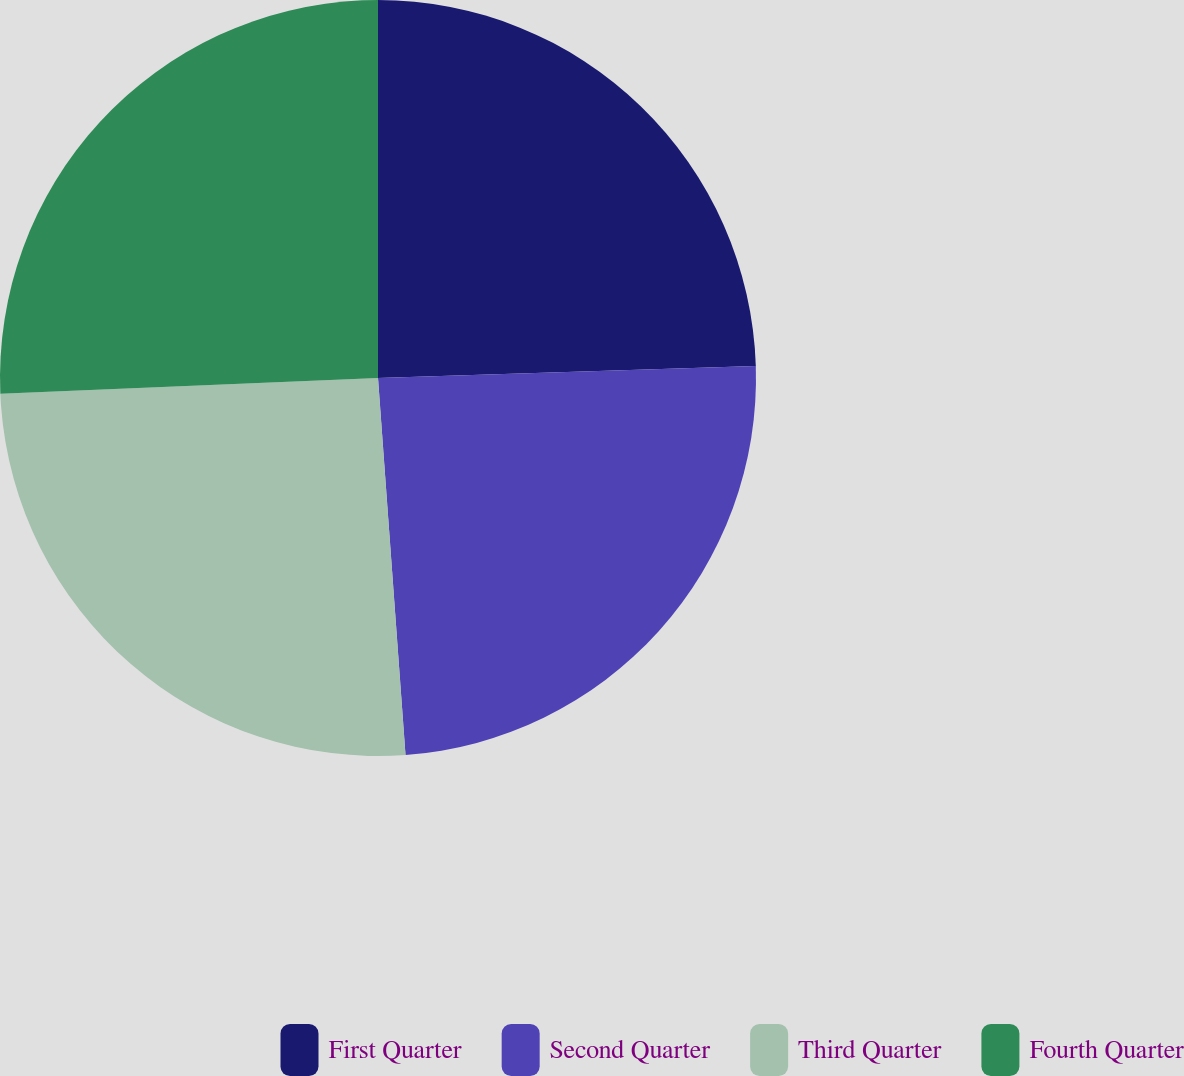Convert chart to OTSL. <chart><loc_0><loc_0><loc_500><loc_500><pie_chart><fcel>First Quarter<fcel>Second Quarter<fcel>Third Quarter<fcel>Fourth Quarter<nl><fcel>24.49%<fcel>24.35%<fcel>25.5%<fcel>25.66%<nl></chart> 